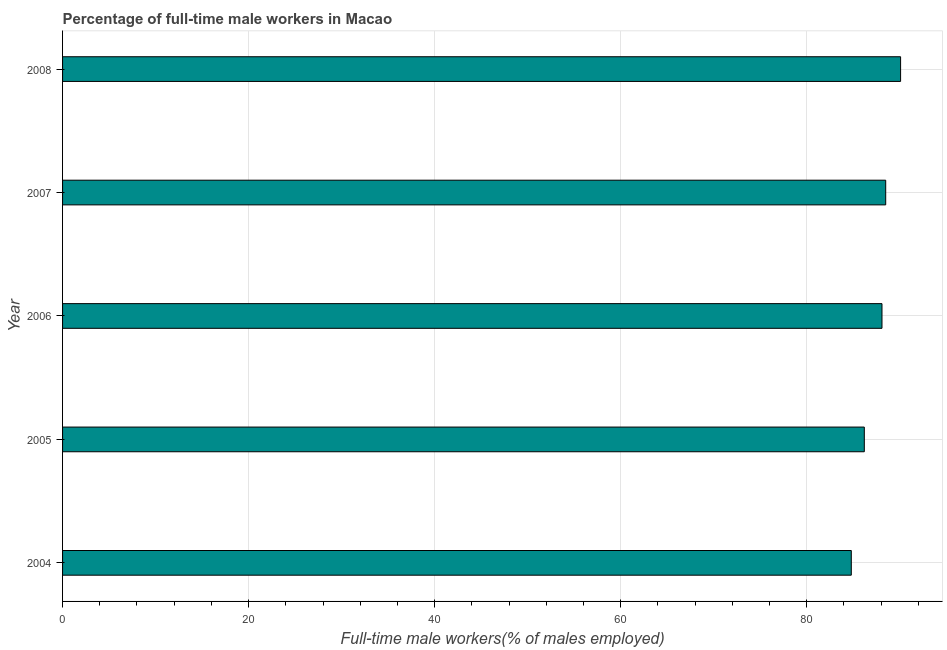What is the title of the graph?
Keep it short and to the point. Percentage of full-time male workers in Macao. What is the label or title of the X-axis?
Ensure brevity in your answer.  Full-time male workers(% of males employed). What is the percentage of full-time male workers in 2005?
Your response must be concise. 86.2. Across all years, what is the maximum percentage of full-time male workers?
Offer a very short reply. 90.1. Across all years, what is the minimum percentage of full-time male workers?
Offer a terse response. 84.8. In which year was the percentage of full-time male workers maximum?
Provide a succinct answer. 2008. In which year was the percentage of full-time male workers minimum?
Your answer should be compact. 2004. What is the sum of the percentage of full-time male workers?
Keep it short and to the point. 437.7. What is the difference between the percentage of full-time male workers in 2005 and 2007?
Give a very brief answer. -2.3. What is the average percentage of full-time male workers per year?
Your answer should be very brief. 87.54. What is the median percentage of full-time male workers?
Provide a short and direct response. 88.1. What is the ratio of the percentage of full-time male workers in 2005 to that in 2007?
Provide a short and direct response. 0.97. Is the percentage of full-time male workers in 2004 less than that in 2006?
Provide a succinct answer. Yes. Is the difference between the percentage of full-time male workers in 2005 and 2006 greater than the difference between any two years?
Ensure brevity in your answer.  No. What is the difference between the highest and the lowest percentage of full-time male workers?
Give a very brief answer. 5.3. In how many years, is the percentage of full-time male workers greater than the average percentage of full-time male workers taken over all years?
Give a very brief answer. 3. Are all the bars in the graph horizontal?
Ensure brevity in your answer.  Yes. Are the values on the major ticks of X-axis written in scientific E-notation?
Your answer should be very brief. No. What is the Full-time male workers(% of males employed) of 2004?
Your response must be concise. 84.8. What is the Full-time male workers(% of males employed) of 2005?
Keep it short and to the point. 86.2. What is the Full-time male workers(% of males employed) of 2006?
Ensure brevity in your answer.  88.1. What is the Full-time male workers(% of males employed) in 2007?
Offer a terse response. 88.5. What is the Full-time male workers(% of males employed) of 2008?
Give a very brief answer. 90.1. What is the difference between the Full-time male workers(% of males employed) in 2004 and 2005?
Make the answer very short. -1.4. What is the difference between the Full-time male workers(% of males employed) in 2004 and 2007?
Offer a very short reply. -3.7. What is the difference between the Full-time male workers(% of males employed) in 2005 and 2006?
Make the answer very short. -1.9. What is the difference between the Full-time male workers(% of males employed) in 2005 and 2008?
Your answer should be very brief. -3.9. What is the difference between the Full-time male workers(% of males employed) in 2006 and 2007?
Ensure brevity in your answer.  -0.4. What is the difference between the Full-time male workers(% of males employed) in 2007 and 2008?
Offer a very short reply. -1.6. What is the ratio of the Full-time male workers(% of males employed) in 2004 to that in 2005?
Your response must be concise. 0.98. What is the ratio of the Full-time male workers(% of males employed) in 2004 to that in 2007?
Make the answer very short. 0.96. What is the ratio of the Full-time male workers(% of males employed) in 2004 to that in 2008?
Provide a short and direct response. 0.94. What is the ratio of the Full-time male workers(% of males employed) in 2005 to that in 2008?
Give a very brief answer. 0.96. What is the ratio of the Full-time male workers(% of males employed) in 2006 to that in 2007?
Offer a very short reply. 0.99. What is the ratio of the Full-time male workers(% of males employed) in 2007 to that in 2008?
Keep it short and to the point. 0.98. 